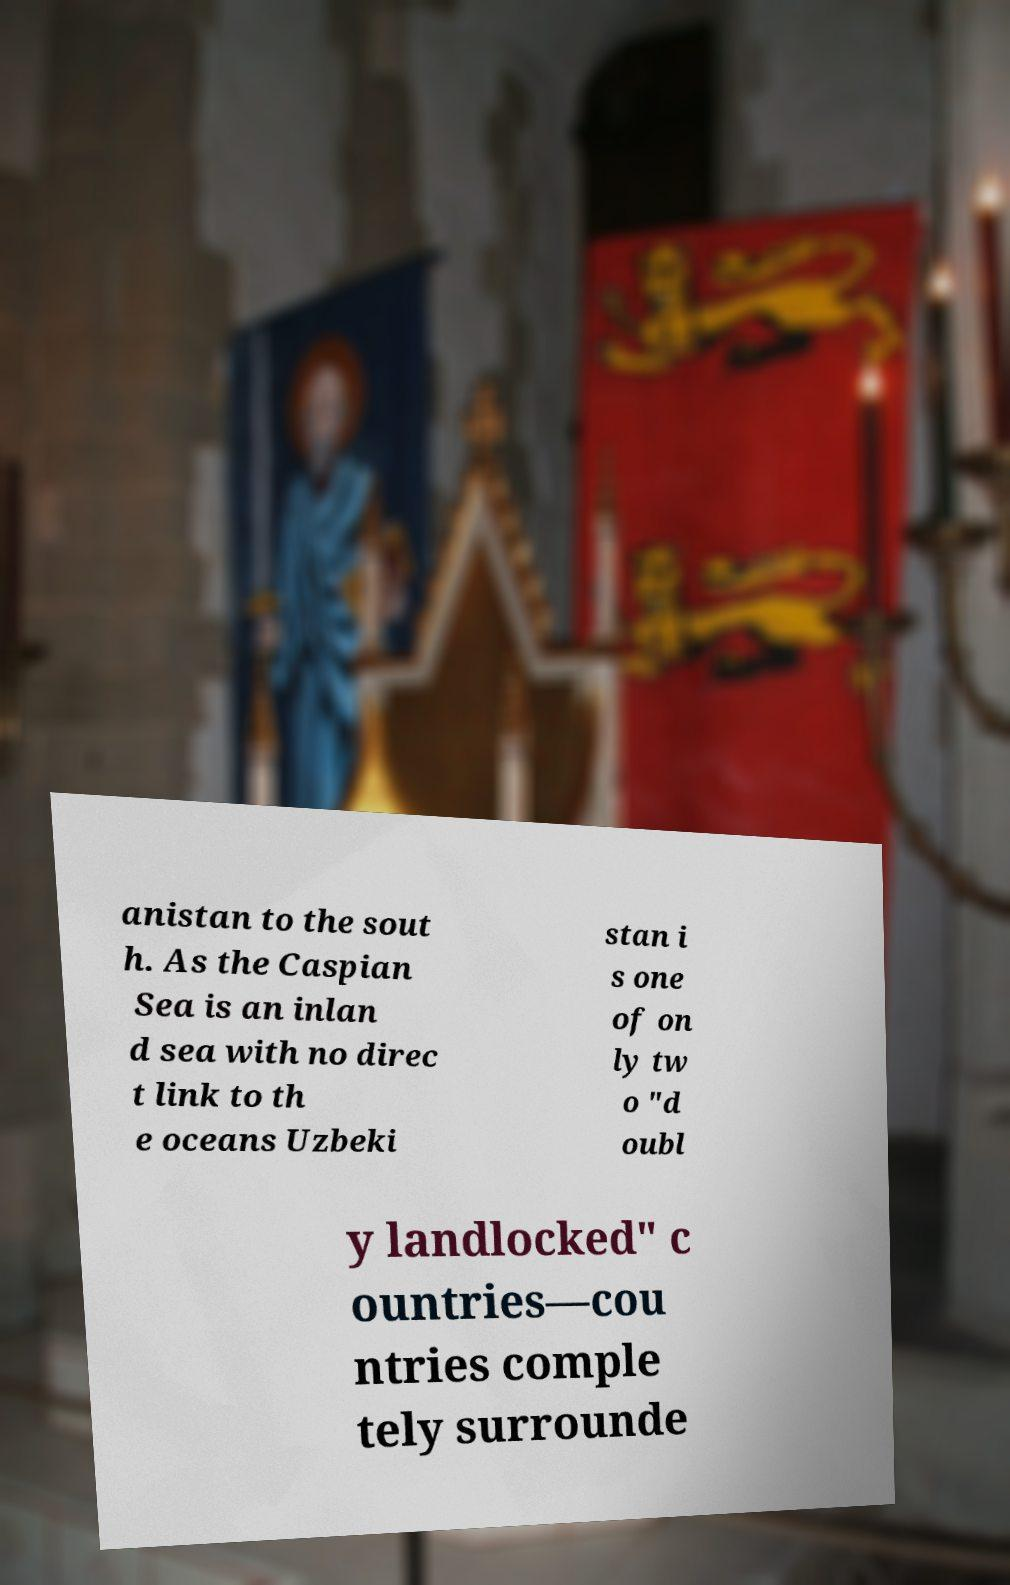For documentation purposes, I need the text within this image transcribed. Could you provide that? anistan to the sout h. As the Caspian Sea is an inlan d sea with no direc t link to th e oceans Uzbeki stan i s one of on ly tw o "d oubl y landlocked" c ountries—cou ntries comple tely surrounde 